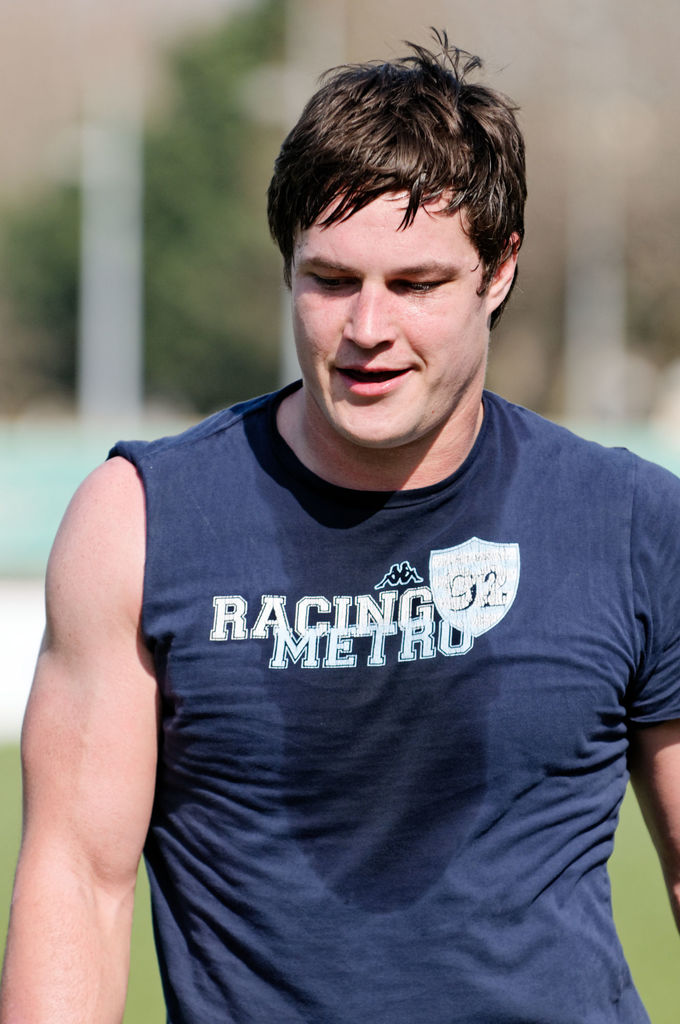What type of sports activity might this person be involved in? Judging by his attire, specifically the 'RACING METRO 92' on the shirt, he could be associated with a rugby team, possibly after a practice session or during a casual workout. 